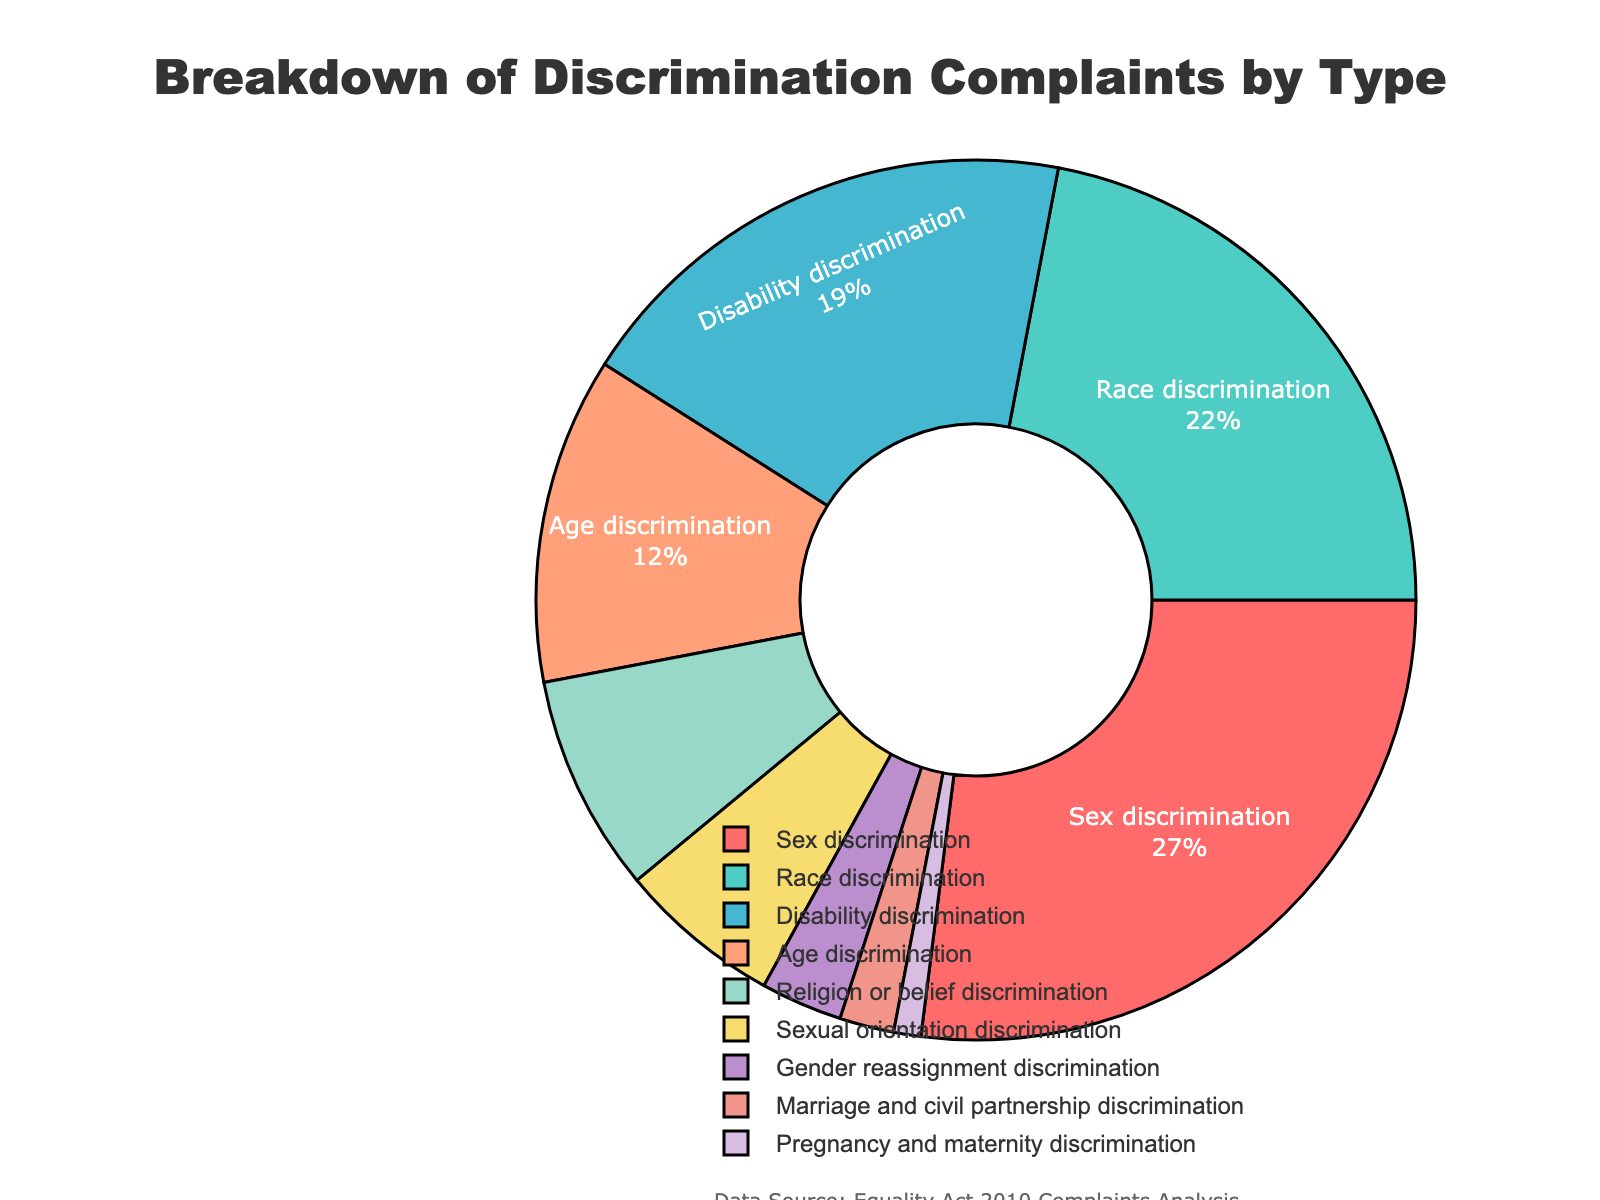Which type of discrimination has the highest percentage of complaints? The pie chart shows the breakdown of discrimination complaints, and by observing the labeled sections, we can see that "Sex discrimination" has the highest percentage.
Answer: Sex discrimination What is the combined percentage of race and disability discrimination complaints? According to the pie chart, race discrimination is 22% and disability discrimination is 19%. Adding them together: 22% + 19% = 41%.
Answer: 41% Which type of discrimination has fewer complaints: sexual orientation or age? From the pie chart, we see that sexual orientation discrimination has 6% and age discrimination has 12%. Comparing these two values, 6% is less than 12%.
Answer: Sexual orientation discrimination What percentage of complaints are related to religion or belief discrimination and pregnancy and maternity discrimination combined? Religion or belief discrimination accounts for 8% and pregnancy and maternity discrimination is 1%. Combining these percentages: 8% + 1% = 9%.
Answer: 9% How many types of discrimination complaints have a percentage less than 5%? Examining the pie chart, we see gender reassignment discrimination (3%), marriage and civil partnership discrimination (2%), and pregnancy and maternity discrimination (1%). There are three types with less than 5%.
Answer: 3 Which type of discrimination complaints has an equal percentage of complaints as sexual orientation discrimination? By examining the pie chart, none of the other types of discrimination have the same percentage (6%) as sexual orientation discrimination.
Answer: None Compare the complaints for sex discrimination to the total complaints for age, religion or belief, and sexual orientation discrimination. Which is higher? Sex discrimination is 27%. Adding age (12%), religion or belief (8%), and sexual orientation discrimination (6%) gives: 12% + 8% + 6% = 26%. Comparing 27% and 26%, 27% is higher.
Answer: Sex discrimination What is the difference in complaints between race discrimination and gender reassignment discrimination? Race discrimination is 22%, and gender reassignment discrimination is 3%. The difference is: 22% - 3% = 19%.
Answer: 19% What visual attributes are used in the chart to differentiate between the types of discrimination? The chart uses different colors to mark each type of discrimination and labels each section with the type and percentage.
Answer: Colors and labels 